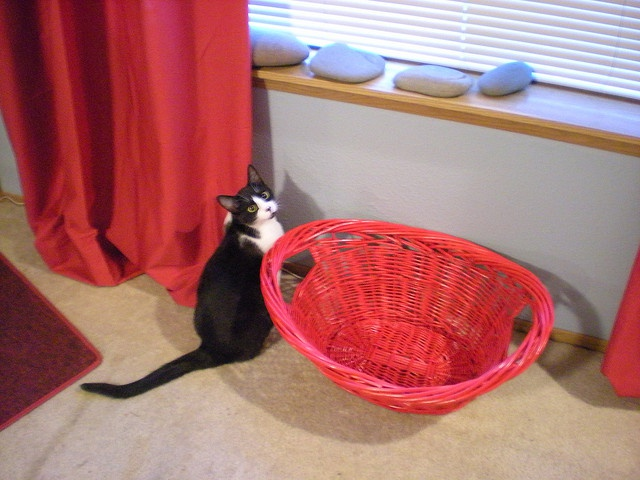Describe the objects in this image and their specific colors. I can see a cat in maroon, black, lightgray, and gray tones in this image. 